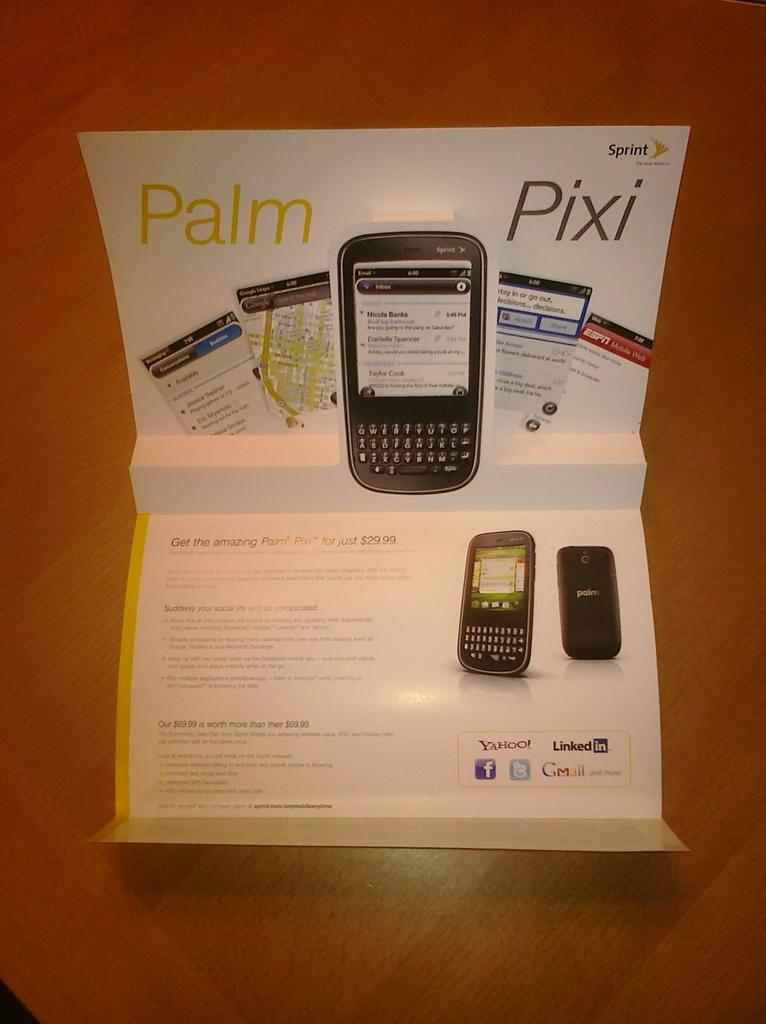<image>
Describe the image concisely. Poster with features of Pixi Palm Pro by Sprint 